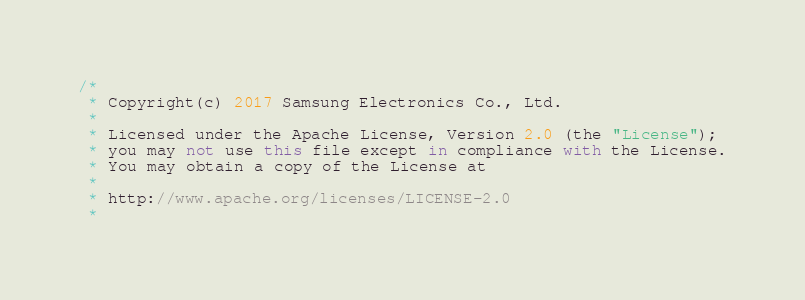Convert code to text. <code><loc_0><loc_0><loc_500><loc_500><_C#_>/*
 * Copyright(c) 2017 Samsung Electronics Co., Ltd.
 *
 * Licensed under the Apache License, Version 2.0 (the "License");
 * you may not use this file except in compliance with the License.
 * You may obtain a copy of the License at
 *
 * http://www.apache.org/licenses/LICENSE-2.0
 *</code> 